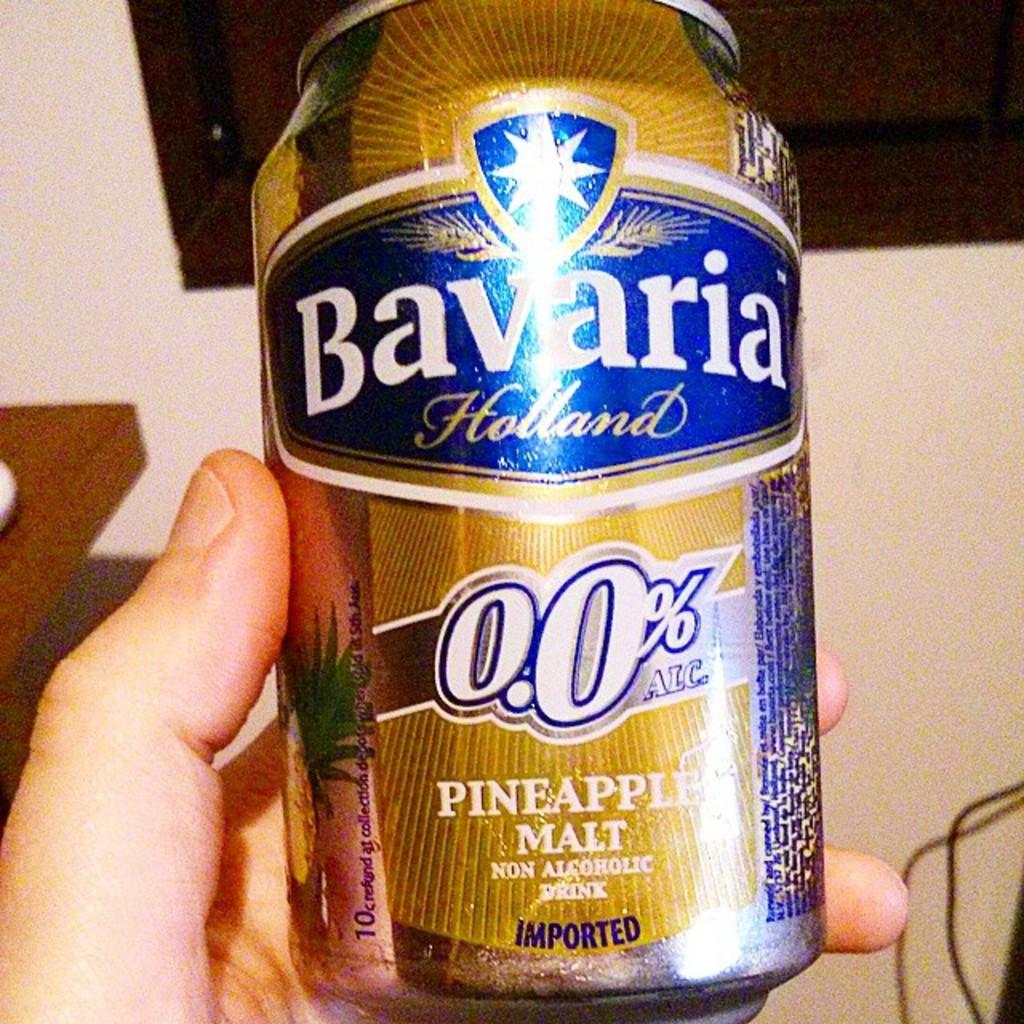Is the can plastic?
Provide a succinct answer. Answering does not require reading text in the image. What fruit flavor is in this beverage?
Your answer should be compact. Pineapple. 